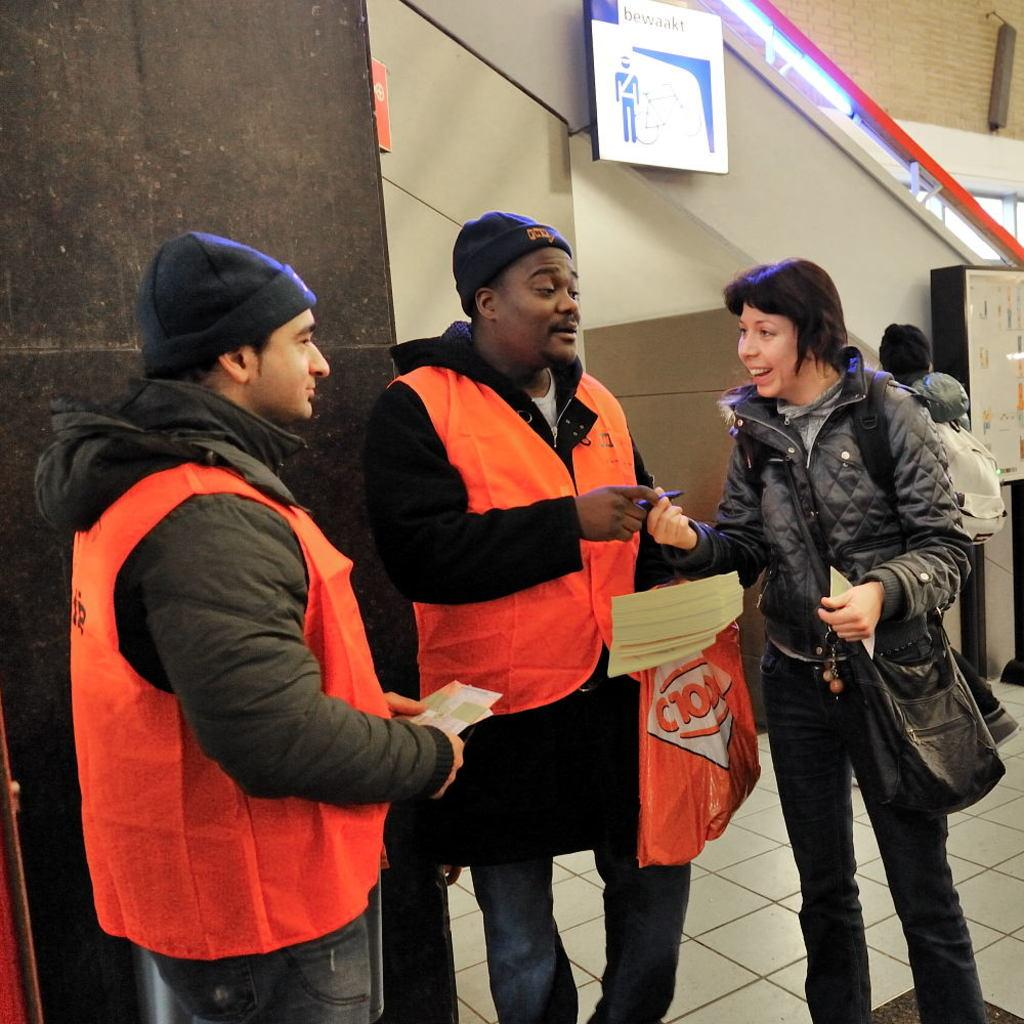What are the people in the image doing? The people in the image are standing and holding papers. Can you describe what one person is carrying? One person is carrying a cover. What can be seen on the wall in the image? There is a board visible in the image. What architectural feature is present in the image? There are stairs in the image. What is the background of the image made of? The background of the image includes a wall. What type of magic trick is being performed by the person carrying the cover? There is no indication of a magic trick being performed in the image; the person is simply carrying a cover. Can you see a flock of birds flying in the image? There are no birds visible in the image. 